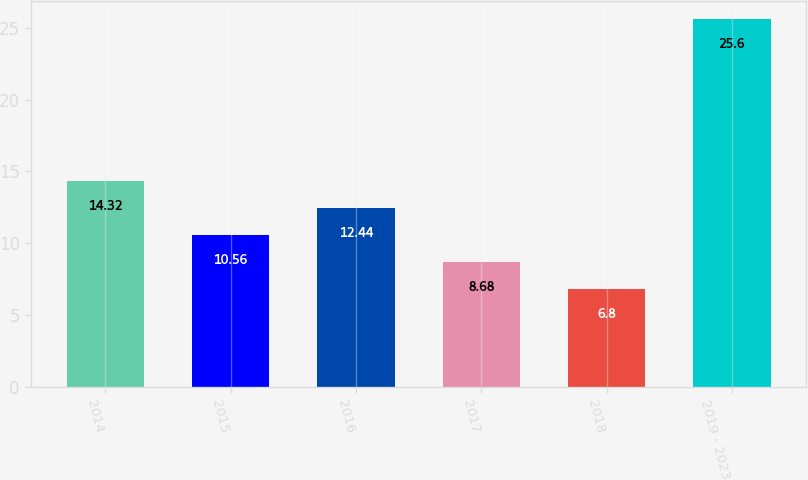Convert chart to OTSL. <chart><loc_0><loc_0><loc_500><loc_500><bar_chart><fcel>2014<fcel>2015<fcel>2016<fcel>2017<fcel>2018<fcel>2019 - 2023<nl><fcel>14.32<fcel>10.56<fcel>12.44<fcel>8.68<fcel>6.8<fcel>25.6<nl></chart> 